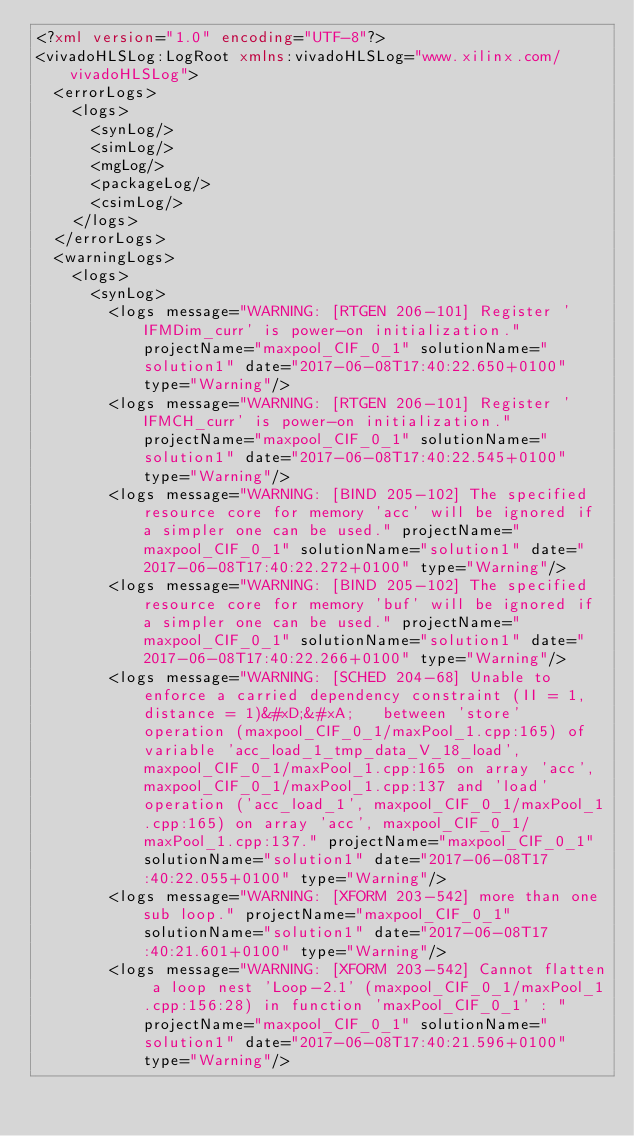<code> <loc_0><loc_0><loc_500><loc_500><_XML_><?xml version="1.0" encoding="UTF-8"?>
<vivadoHLSLog:LogRoot xmlns:vivadoHLSLog="www.xilinx.com/vivadoHLSLog">
  <errorLogs>
    <logs>
      <synLog/>
      <simLog/>
      <mgLog/>
      <packageLog/>
      <csimLog/>
    </logs>
  </errorLogs>
  <warningLogs>
    <logs>
      <synLog>
        <logs message="WARNING: [RTGEN 206-101] Register 'IFMDim_curr' is power-on initialization." projectName="maxpool_CIF_0_1" solutionName="solution1" date="2017-06-08T17:40:22.650+0100" type="Warning"/>
        <logs message="WARNING: [RTGEN 206-101] Register 'IFMCH_curr' is power-on initialization." projectName="maxpool_CIF_0_1" solutionName="solution1" date="2017-06-08T17:40:22.545+0100" type="Warning"/>
        <logs message="WARNING: [BIND 205-102] The specified resource core for memory 'acc' will be ignored if a simpler one can be used." projectName="maxpool_CIF_0_1" solutionName="solution1" date="2017-06-08T17:40:22.272+0100" type="Warning"/>
        <logs message="WARNING: [BIND 205-102] The specified resource core for memory 'buf' will be ignored if a simpler one can be used." projectName="maxpool_CIF_0_1" solutionName="solution1" date="2017-06-08T17:40:22.266+0100" type="Warning"/>
        <logs message="WARNING: [SCHED 204-68] Unable to enforce a carried dependency constraint (II = 1, distance = 1)&#xD;&#xA;   between 'store' operation (maxpool_CIF_0_1/maxPool_1.cpp:165) of variable 'acc_load_1_tmp_data_V_18_load', maxpool_CIF_0_1/maxPool_1.cpp:165 on array 'acc', maxpool_CIF_0_1/maxPool_1.cpp:137 and 'load' operation ('acc_load_1', maxpool_CIF_0_1/maxPool_1.cpp:165) on array 'acc', maxpool_CIF_0_1/maxPool_1.cpp:137." projectName="maxpool_CIF_0_1" solutionName="solution1" date="2017-06-08T17:40:22.055+0100" type="Warning"/>
        <logs message="WARNING: [XFORM 203-542] more than one sub loop." projectName="maxpool_CIF_0_1" solutionName="solution1" date="2017-06-08T17:40:21.601+0100" type="Warning"/>
        <logs message="WARNING: [XFORM 203-542] Cannot flatten a loop nest 'Loop-2.1' (maxpool_CIF_0_1/maxPool_1.cpp:156:28) in function 'maxPool_CIF_0_1' : " projectName="maxpool_CIF_0_1" solutionName="solution1" date="2017-06-08T17:40:21.596+0100" type="Warning"/></code> 